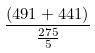<formula> <loc_0><loc_0><loc_500><loc_500>\frac { ( 4 9 1 + 4 4 1 ) } { \frac { 2 7 5 } { 5 } }</formula> 